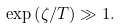<formula> <loc_0><loc_0><loc_500><loc_500>\exp \left ( \zeta / T \right ) \gg 1 .</formula> 